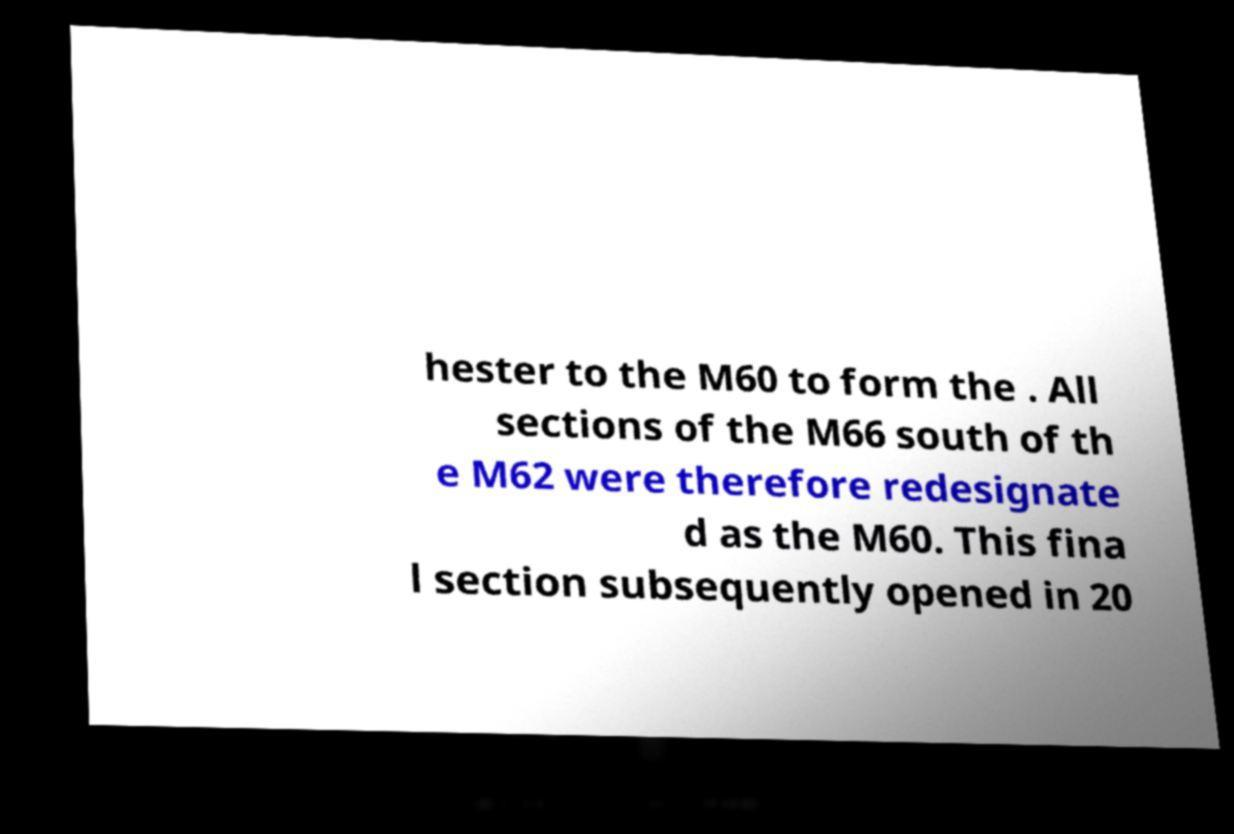Could you assist in decoding the text presented in this image and type it out clearly? hester to the M60 to form the . All sections of the M66 south of th e M62 were therefore redesignate d as the M60. This fina l section subsequently opened in 20 